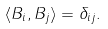Convert formula to latex. <formula><loc_0><loc_0><loc_500><loc_500>\langle { B } _ { i } , { B } _ { j } \rangle = \delta _ { i j } .</formula> 